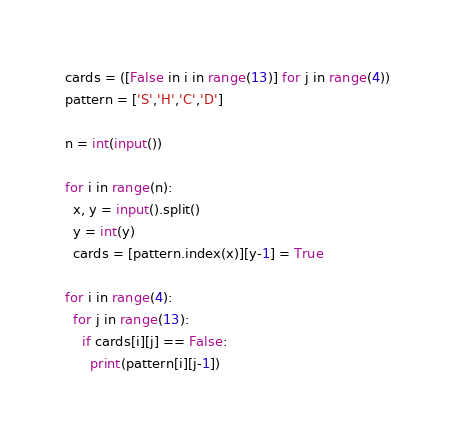<code> <loc_0><loc_0><loc_500><loc_500><_Python_>cards = ([False in i in range(13)] for j in range(4))
pattern = ['S','H','C','D']

n = int(input())

for i in range(n):
  x, y = input().split()
  y = int(y)
  cards = [pattern.index(x)][y-1] = True
  
for i in range(4):
  for j in range(13):
    if cards[i][j] == False:
      print(pattern[i][j-1])
</code> 